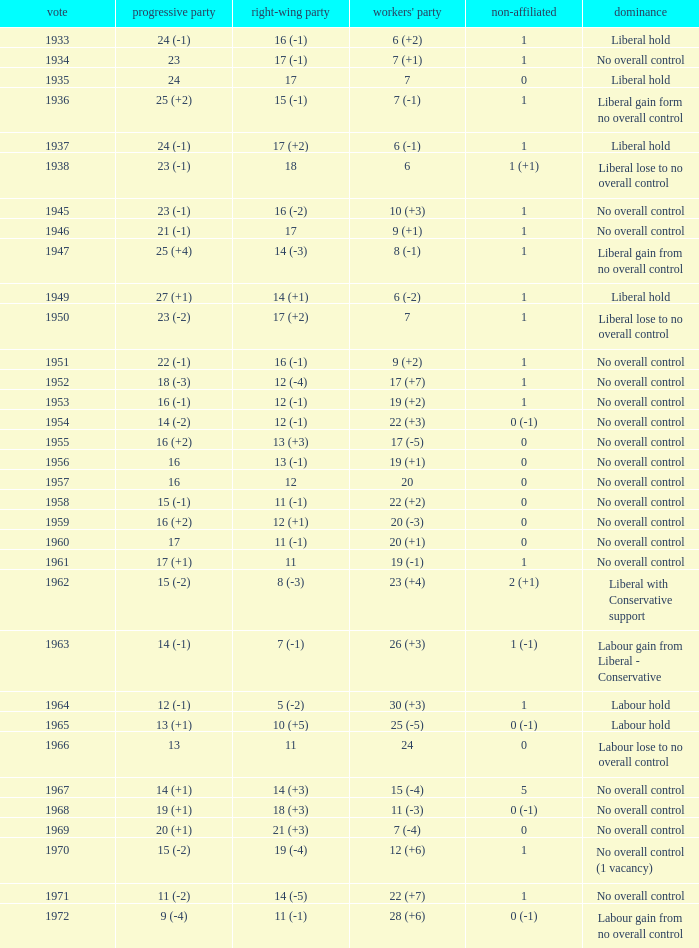What was the control for the year with a Conservative Party result of 10 (+5)? Labour hold. 